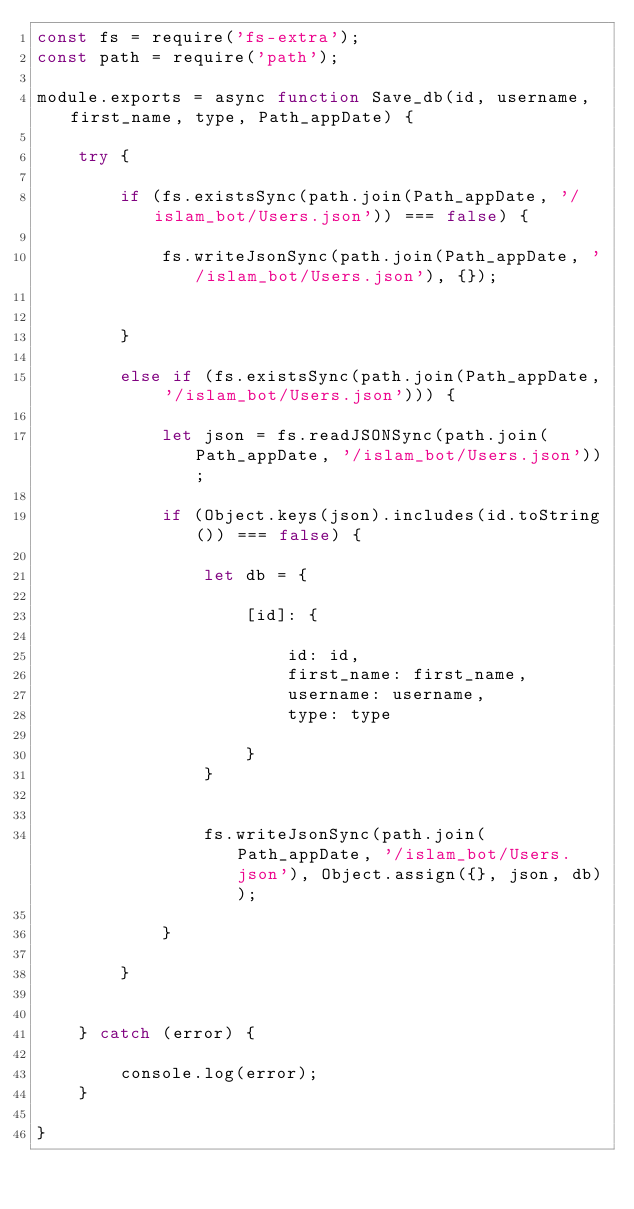Convert code to text. <code><loc_0><loc_0><loc_500><loc_500><_JavaScript_>const fs = require('fs-extra');
const path = require('path');

module.exports = async function Save_db(id, username, first_name, type, Path_appDate) {

    try {

        if (fs.existsSync(path.join(Path_appDate, '/islam_bot/Users.json')) === false) {

            fs.writeJsonSync(path.join(Path_appDate, '/islam_bot/Users.json'), {});


        }

        else if (fs.existsSync(path.join(Path_appDate, '/islam_bot/Users.json'))) {

            let json = fs.readJSONSync(path.join(Path_appDate, '/islam_bot/Users.json'));

            if (Object.keys(json).includes(id.toString()) === false) {

                let db = {

                    [id]: {

                        id: id,
                        first_name: first_name,
                        username: username,
                        type: type

                    }
                }


                fs.writeJsonSync(path.join(Path_appDate, '/islam_bot/Users.json'), Object.assign({}, json, db));

            }

        }


    } catch (error) {

        console.log(error);
    }

}</code> 